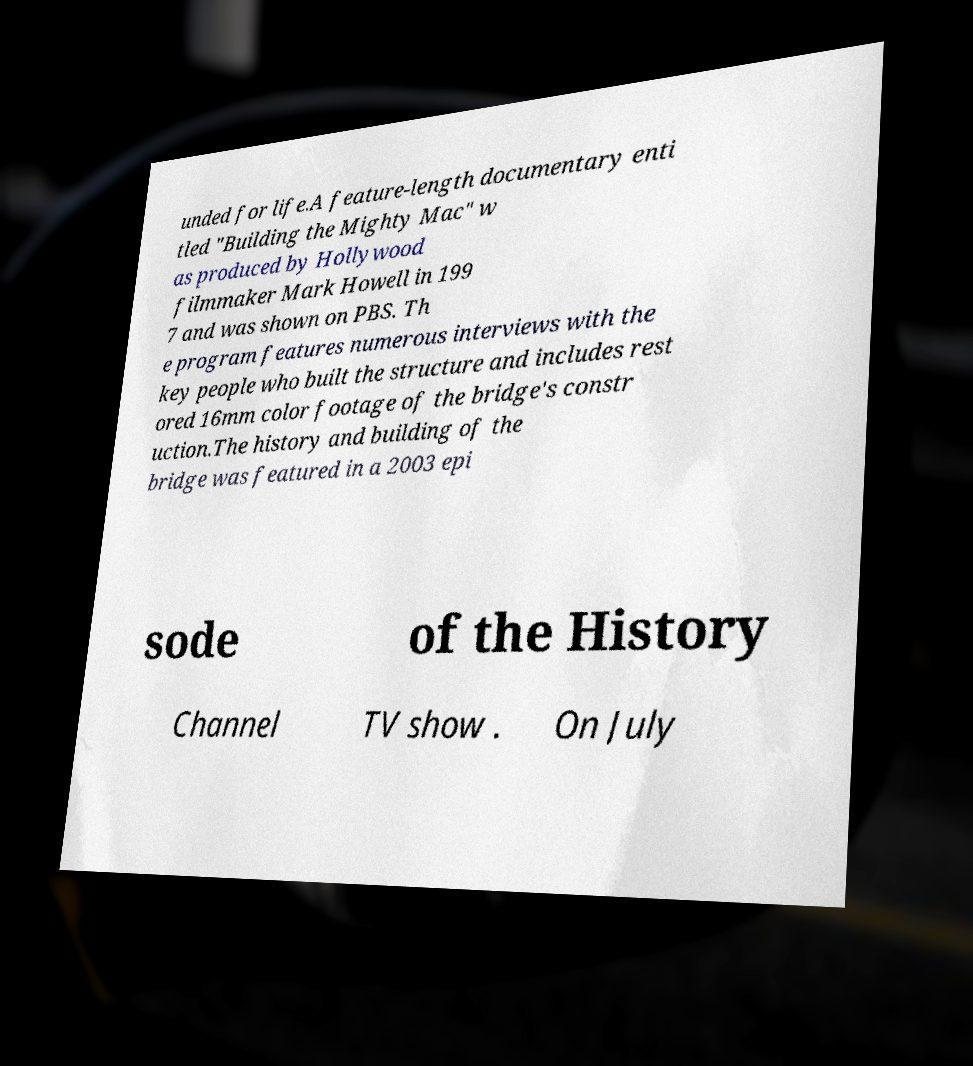I need the written content from this picture converted into text. Can you do that? unded for life.A feature-length documentary enti tled "Building the Mighty Mac" w as produced by Hollywood filmmaker Mark Howell in 199 7 and was shown on PBS. Th e program features numerous interviews with the key people who built the structure and includes rest ored 16mm color footage of the bridge's constr uction.The history and building of the bridge was featured in a 2003 epi sode of the History Channel TV show . On July 